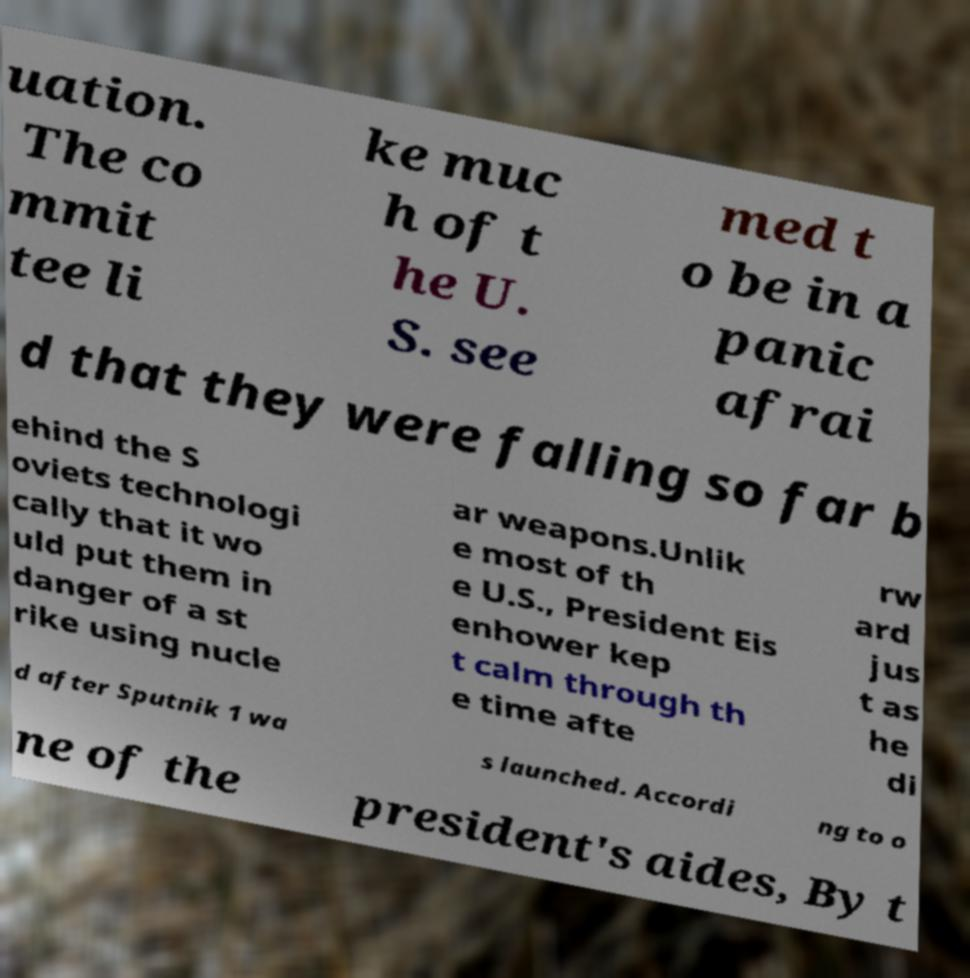Please identify and transcribe the text found in this image. uation. The co mmit tee li ke muc h of t he U. S. see med t o be in a panic afrai d that they were falling so far b ehind the S oviets technologi cally that it wo uld put them in danger of a st rike using nucle ar weapons.Unlik e most of th e U.S., President Eis enhower kep t calm through th e time afte rw ard jus t as he di d after Sputnik 1 wa s launched. Accordi ng to o ne of the president's aides, By t 